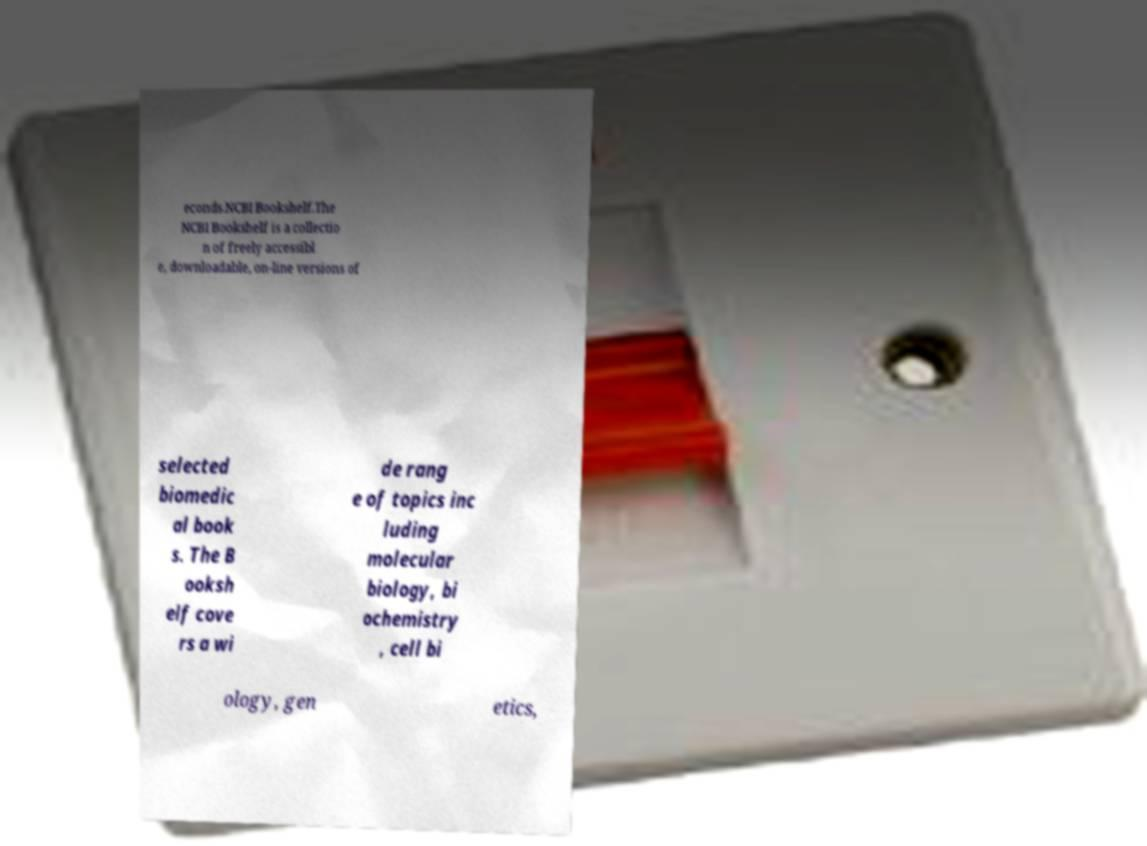I need the written content from this picture converted into text. Can you do that? econds.NCBI Bookshelf.The NCBI Bookshelf is a collectio n of freely accessibl e, downloadable, on-line versions of selected biomedic al book s. The B ooksh elf cove rs a wi de rang e of topics inc luding molecular biology, bi ochemistry , cell bi ology, gen etics, 